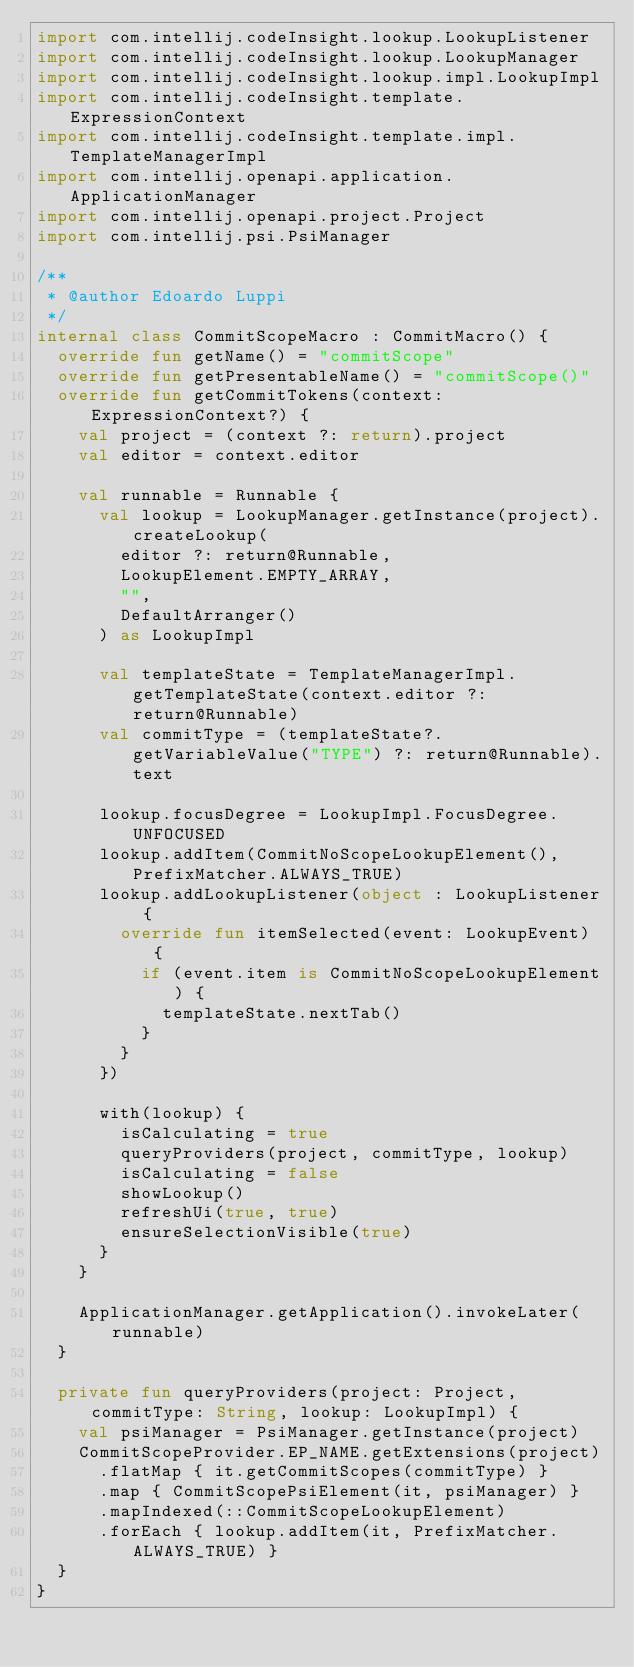<code> <loc_0><loc_0><loc_500><loc_500><_Kotlin_>import com.intellij.codeInsight.lookup.LookupListener
import com.intellij.codeInsight.lookup.LookupManager
import com.intellij.codeInsight.lookup.impl.LookupImpl
import com.intellij.codeInsight.template.ExpressionContext
import com.intellij.codeInsight.template.impl.TemplateManagerImpl
import com.intellij.openapi.application.ApplicationManager
import com.intellij.openapi.project.Project
import com.intellij.psi.PsiManager

/**
 * @author Edoardo Luppi
 */
internal class CommitScopeMacro : CommitMacro() {
  override fun getName() = "commitScope"
  override fun getPresentableName() = "commitScope()"
  override fun getCommitTokens(context: ExpressionContext?) {
    val project = (context ?: return).project
    val editor = context.editor

    val runnable = Runnable {
      val lookup = LookupManager.getInstance(project).createLookup(
        editor ?: return@Runnable,
        LookupElement.EMPTY_ARRAY,
        "",
        DefaultArranger()
      ) as LookupImpl

      val templateState = TemplateManagerImpl.getTemplateState(context.editor ?: return@Runnable)
      val commitType = (templateState?.getVariableValue("TYPE") ?: return@Runnable).text

      lookup.focusDegree = LookupImpl.FocusDegree.UNFOCUSED
      lookup.addItem(CommitNoScopeLookupElement(), PrefixMatcher.ALWAYS_TRUE)
      lookup.addLookupListener(object : LookupListener {
        override fun itemSelected(event: LookupEvent) {
          if (event.item is CommitNoScopeLookupElement) {
            templateState.nextTab()
          }
        }
      })

      with(lookup) {
        isCalculating = true
        queryProviders(project, commitType, lookup)
        isCalculating = false
        showLookup()
        refreshUi(true, true)
        ensureSelectionVisible(true)
      }
    }

    ApplicationManager.getApplication().invokeLater(runnable)
  }

  private fun queryProviders(project: Project, commitType: String, lookup: LookupImpl) {
    val psiManager = PsiManager.getInstance(project)
    CommitScopeProvider.EP_NAME.getExtensions(project)
      .flatMap { it.getCommitScopes(commitType) }
      .map { CommitScopePsiElement(it, psiManager) }
      .mapIndexed(::CommitScopeLookupElement)
      .forEach { lookup.addItem(it, PrefixMatcher.ALWAYS_TRUE) }
  }
}
</code> 